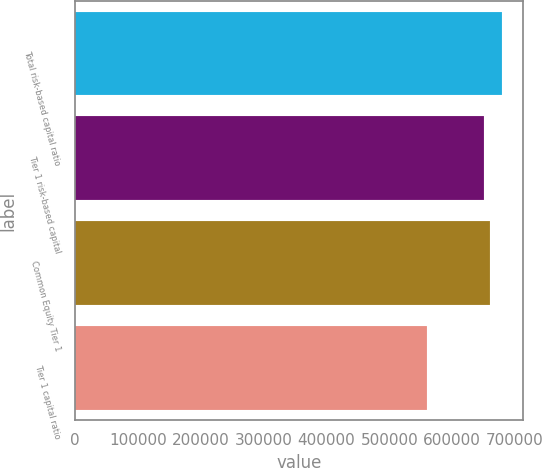Convert chart. <chart><loc_0><loc_0><loc_500><loc_500><bar_chart><fcel>Total risk-based capital ratio<fcel>Tier 1 risk-based capital<fcel>Common Equity Tier 1<fcel>Tier 1 capital ratio<nl><fcel>678831<fcel>650487<fcel>659935<fcel>559572<nl></chart> 